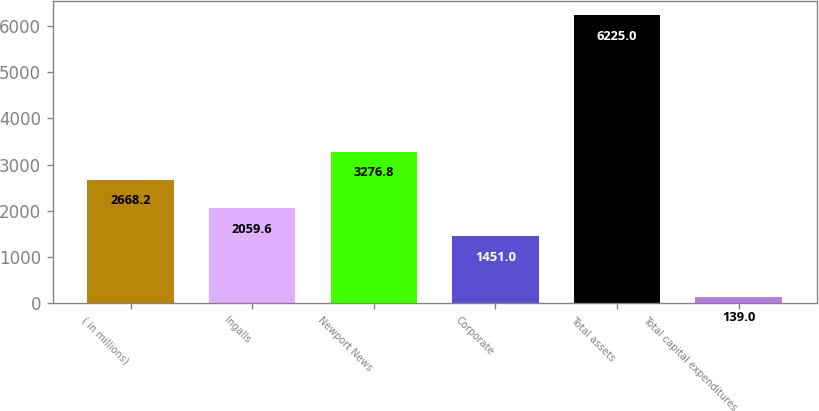Convert chart. <chart><loc_0><loc_0><loc_500><loc_500><bar_chart><fcel>( in millions)<fcel>Ingalls<fcel>Newport News<fcel>Corporate<fcel>Total assets<fcel>Total capital expenditures<nl><fcel>2668.2<fcel>2059.6<fcel>3276.8<fcel>1451<fcel>6225<fcel>139<nl></chart> 